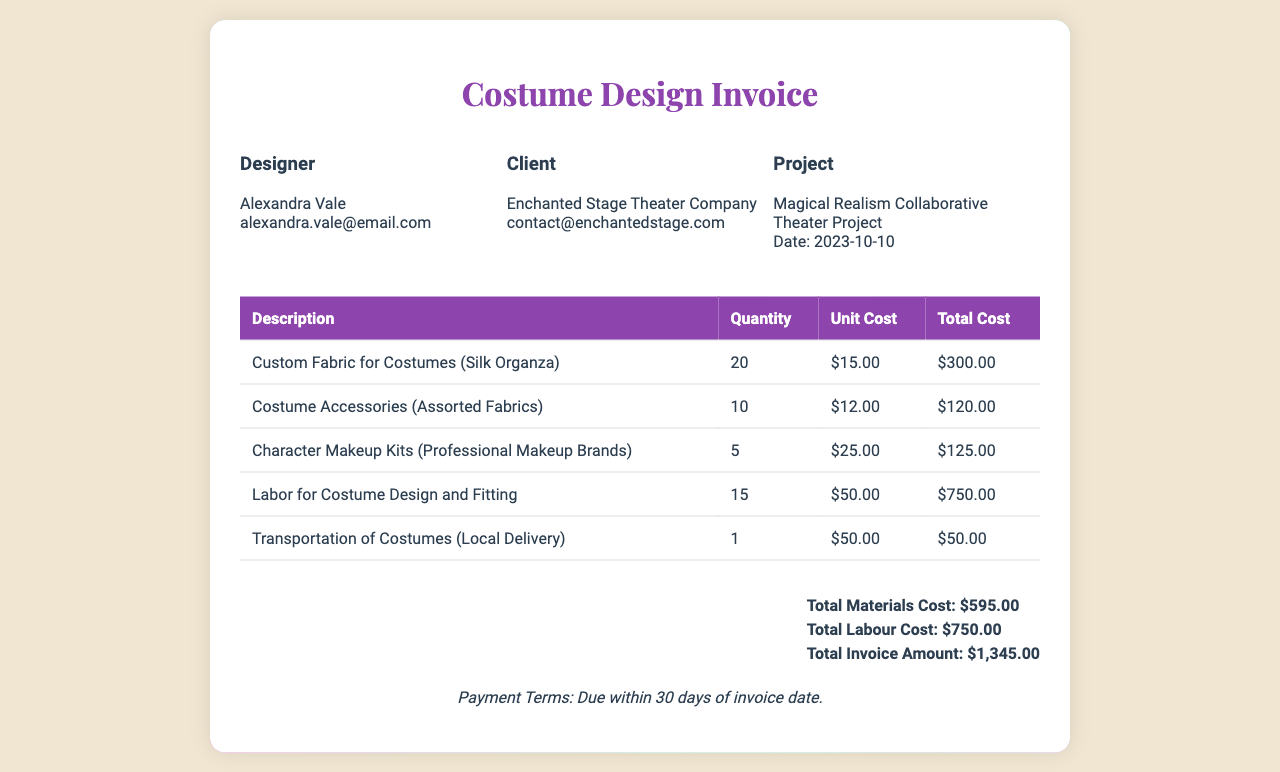what is the designer's name? The designer's name is listed in the document as Alexandra Vale.
Answer: Alexandra Vale what is the total invoice amount? The total invoice amount is provided in the summary section of the document as $1,345.00.
Answer: $1,345.00 how many costume accessories were included? The document states that 10 costume accessories were included in the invoice.
Answer: 10 what is the payment term for this invoice? The payment terms are specified at the bottom of the invoice as due within 30 days of invoice date.
Answer: Due within 30 days what is the unit cost of Custom Fabric for Costumes? The document lists the unit cost of Custom Fabric for Costumes as $15.00.
Answer: $15.00 how many items were charged for character makeup kits? The document indicates that 5 character makeup kits were charged.
Answer: 5 what is the total labour cost? The total labour cost is detailed in the summary section as $750.00.
Answer: $750.00 which theater company is the client? The client is identified in the document as Enchanted Stage Theater Company.
Answer: Enchanted Stage Theater Company 